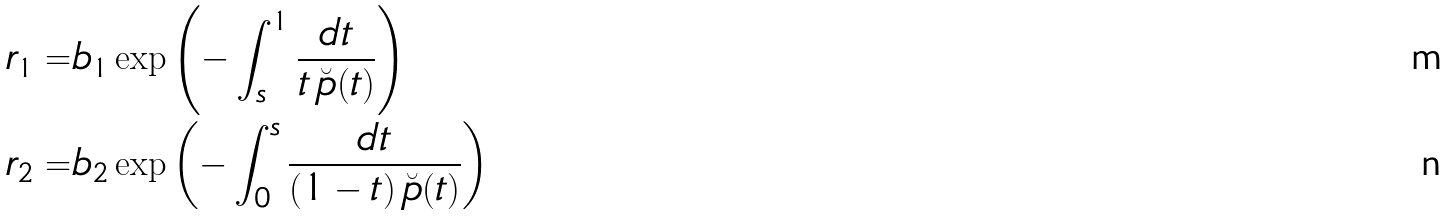<formula> <loc_0><loc_0><loc_500><loc_500>r _ { 1 } = & b _ { 1 } \exp \left ( - \int _ { s } ^ { 1 } \frac { d t } { t \, \breve { p } ( t ) } \right ) \\ r _ { 2 } = & b _ { 2 } \exp \left ( - \int _ { 0 } ^ { s } \frac { d t } { ( 1 - t ) \, \breve { p } ( t ) } \right )</formula> 